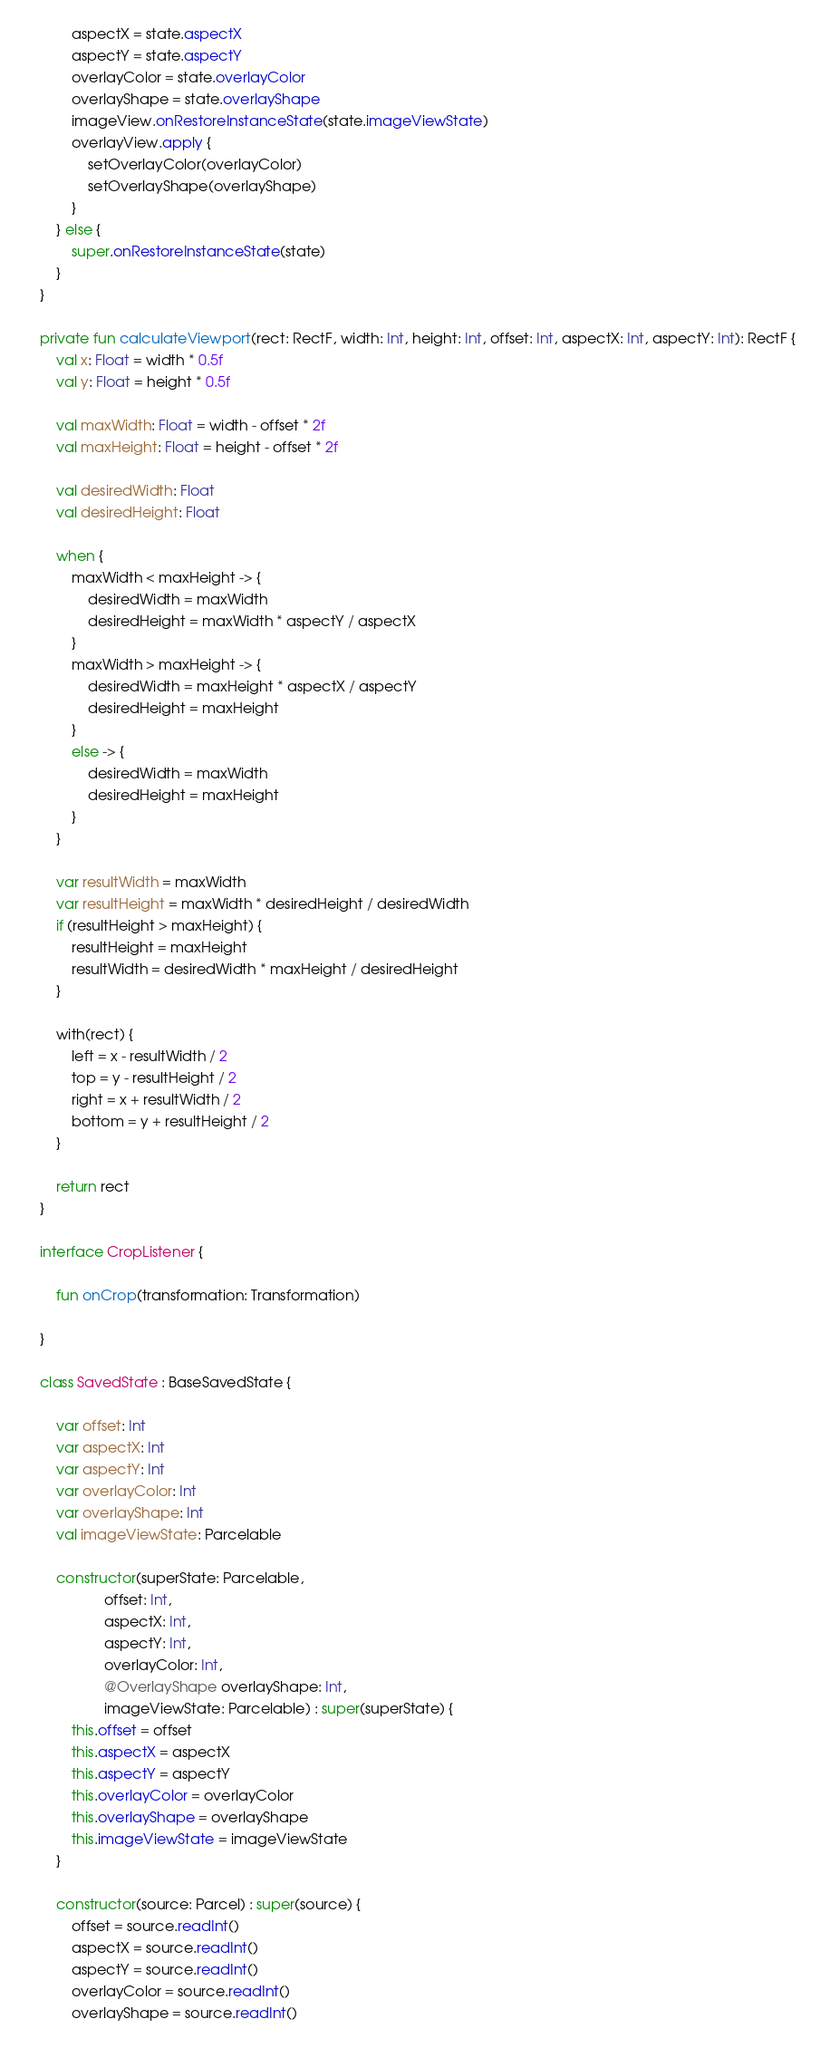Convert code to text. <code><loc_0><loc_0><loc_500><loc_500><_Kotlin_>            aspectX = state.aspectX
            aspectY = state.aspectY
            overlayColor = state.overlayColor
            overlayShape = state.overlayShape
            imageView.onRestoreInstanceState(state.imageViewState)
            overlayView.apply {
                setOverlayColor(overlayColor)
                setOverlayShape(overlayShape)
            }
        } else {
            super.onRestoreInstanceState(state)
        }
    }

    private fun calculateViewport(rect: RectF, width: Int, height: Int, offset: Int, aspectX: Int, aspectY: Int): RectF {
        val x: Float = width * 0.5f
        val y: Float = height * 0.5f

        val maxWidth: Float = width - offset * 2f
        val maxHeight: Float = height - offset * 2f

        val desiredWidth: Float
        val desiredHeight: Float

        when {
            maxWidth < maxHeight -> {
                desiredWidth = maxWidth
                desiredHeight = maxWidth * aspectY / aspectX
            }
            maxWidth > maxHeight -> {
                desiredWidth = maxHeight * aspectX / aspectY
                desiredHeight = maxHeight
            }
            else -> {
                desiredWidth = maxWidth
                desiredHeight = maxHeight
            }
        }

        var resultWidth = maxWidth
        var resultHeight = maxWidth * desiredHeight / desiredWidth
        if (resultHeight > maxHeight) {
            resultHeight = maxHeight
            resultWidth = desiredWidth * maxHeight / desiredHeight
        }

        with(rect) {
            left = x - resultWidth / 2
            top = y - resultHeight / 2
            right = x + resultWidth / 2
            bottom = y + resultHeight / 2
        }

        return rect
    }

    interface CropListener {

        fun onCrop(transformation: Transformation)

    }

    class SavedState : BaseSavedState {

        var offset: Int
        var aspectX: Int
        var aspectY: Int
        var overlayColor: Int
        var overlayShape: Int
        val imageViewState: Parcelable

        constructor(superState: Parcelable,
                    offset: Int,
                    aspectX: Int,
                    aspectY: Int,
                    overlayColor: Int,
                    @OverlayShape overlayShape: Int,
                    imageViewState: Parcelable) : super(superState) {
            this.offset = offset
            this.aspectX = aspectX
            this.aspectY = aspectY
            this.overlayColor = overlayColor
            this.overlayShape = overlayShape
            this.imageViewState = imageViewState
        }

        constructor(source: Parcel) : super(source) {
            offset = source.readInt()
            aspectX = source.readInt()
            aspectY = source.readInt()
            overlayColor = source.readInt()
            overlayShape = source.readInt()</code> 